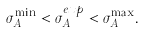Convert formula to latex. <formula><loc_0><loc_0><loc_500><loc_500>\sigma _ { A } ^ { \min } < \sigma _ { A } ^ { e x p } < \sigma _ { A } ^ { \max } .</formula> 